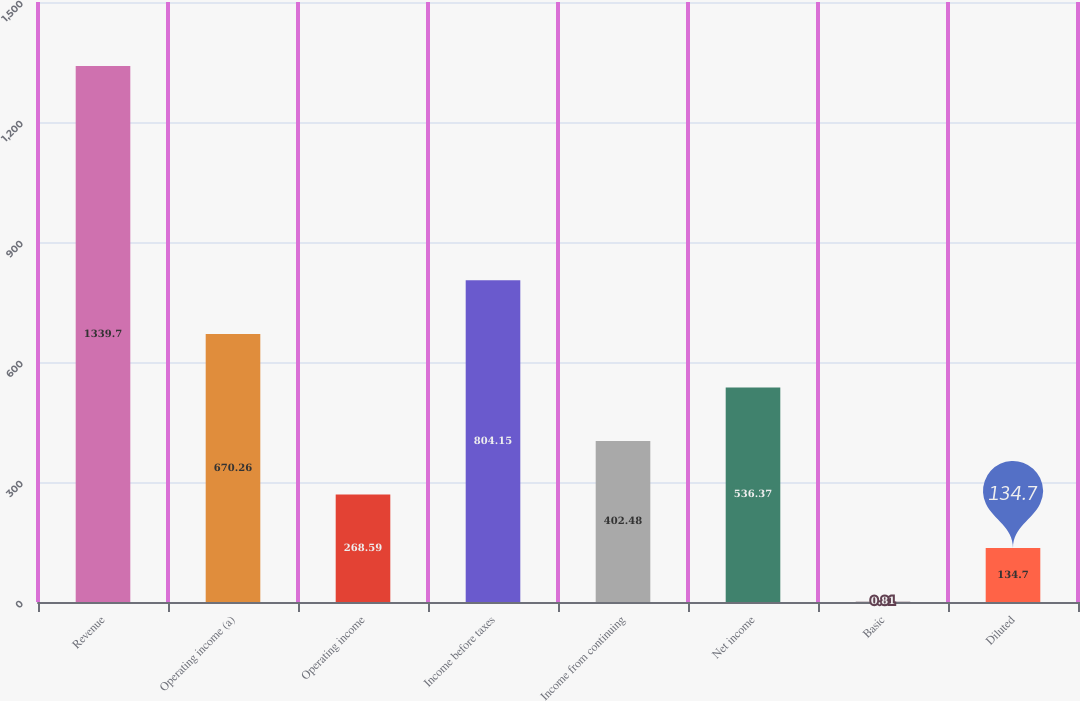Convert chart to OTSL. <chart><loc_0><loc_0><loc_500><loc_500><bar_chart><fcel>Revenue<fcel>Operating income (a)<fcel>Operating income<fcel>Income before taxes<fcel>Income from continuing<fcel>Net income<fcel>Basic<fcel>Diluted<nl><fcel>1339.7<fcel>670.26<fcel>268.59<fcel>804.15<fcel>402.48<fcel>536.37<fcel>0.81<fcel>134.7<nl></chart> 